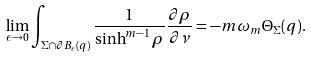<formula> <loc_0><loc_0><loc_500><loc_500>\lim _ { \epsilon \rightarrow 0 } \int _ { \Sigma \cap \partial B _ { \epsilon } ( q ) } \frac { 1 } { \sinh ^ { m - 1 } \rho } \frac { \partial \rho } { \partial \nu } = - m \omega _ { m } \Theta _ { \Sigma } ( q ) .</formula> 